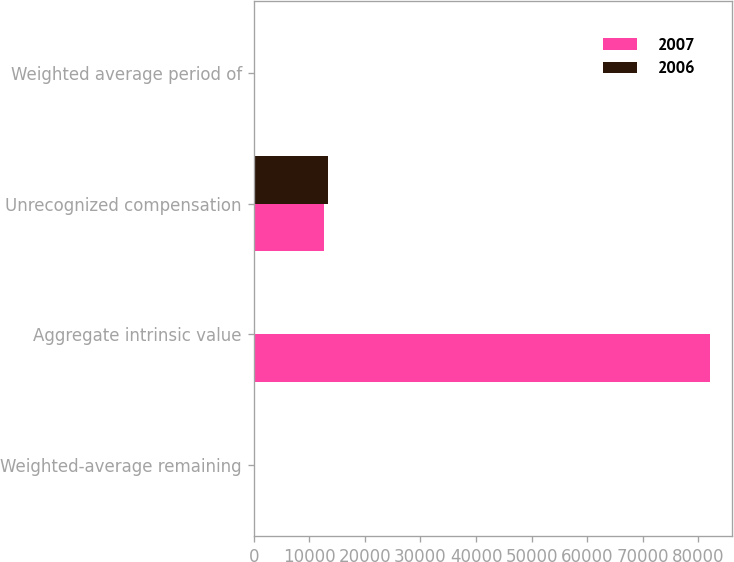Convert chart. <chart><loc_0><loc_0><loc_500><loc_500><stacked_bar_chart><ecel><fcel>Weighted-average remaining<fcel>Aggregate intrinsic value<fcel>Unrecognized compensation<fcel>Weighted average period of<nl><fcel>2007<fcel>4.74<fcel>82006<fcel>12692<fcel>1.65<nl><fcel>2006<fcel>5.52<fcel>5.52<fcel>13414<fcel>2.46<nl></chart> 